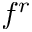Convert formula to latex. <formula><loc_0><loc_0><loc_500><loc_500>f ^ { r }</formula> 